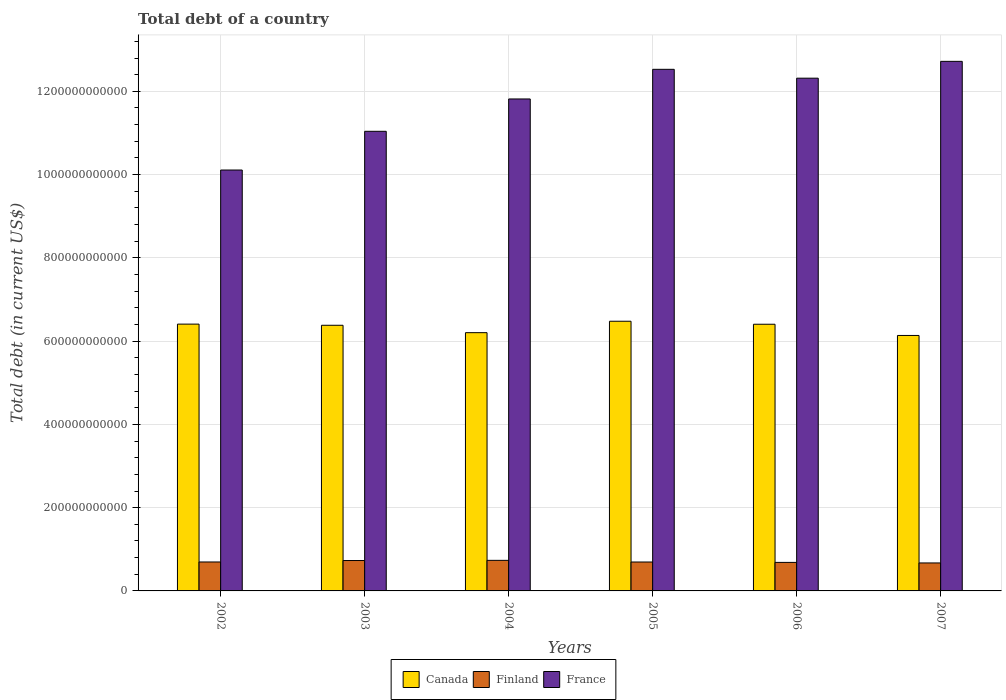How many different coloured bars are there?
Offer a terse response. 3. How many groups of bars are there?
Make the answer very short. 6. Are the number of bars per tick equal to the number of legend labels?
Make the answer very short. Yes. Are the number of bars on each tick of the X-axis equal?
Give a very brief answer. Yes. What is the label of the 2nd group of bars from the left?
Provide a short and direct response. 2003. What is the debt in Canada in 2002?
Keep it short and to the point. 6.41e+11. Across all years, what is the maximum debt in France?
Make the answer very short. 1.27e+12. Across all years, what is the minimum debt in Finland?
Ensure brevity in your answer.  6.72e+1. In which year was the debt in Finland minimum?
Keep it short and to the point. 2007. What is the total debt in France in the graph?
Make the answer very short. 7.05e+12. What is the difference between the debt in France in 2005 and that in 2006?
Your answer should be compact. 2.13e+1. What is the difference between the debt in France in 2002 and the debt in Canada in 2004?
Keep it short and to the point. 3.91e+11. What is the average debt in Canada per year?
Ensure brevity in your answer.  6.34e+11. In the year 2005, what is the difference between the debt in France and debt in Canada?
Keep it short and to the point. 6.05e+11. What is the ratio of the debt in Finland in 2003 to that in 2004?
Provide a succinct answer. 0.99. Is the difference between the debt in France in 2002 and 2007 greater than the difference between the debt in Canada in 2002 and 2007?
Keep it short and to the point. No. What is the difference between the highest and the second highest debt in Canada?
Make the answer very short. 6.89e+09. What is the difference between the highest and the lowest debt in France?
Give a very brief answer. 2.61e+11. What does the 2nd bar from the right in 2006 represents?
Provide a succinct answer. Finland. How many bars are there?
Ensure brevity in your answer.  18. Are all the bars in the graph horizontal?
Your answer should be very brief. No. What is the difference between two consecutive major ticks on the Y-axis?
Provide a succinct answer. 2.00e+11. Does the graph contain grids?
Offer a very short reply. Yes. How many legend labels are there?
Keep it short and to the point. 3. What is the title of the graph?
Your answer should be very brief. Total debt of a country. Does "Puerto Rico" appear as one of the legend labels in the graph?
Your answer should be compact. No. What is the label or title of the Y-axis?
Offer a very short reply. Total debt (in current US$). What is the Total debt (in current US$) of Canada in 2002?
Offer a terse response. 6.41e+11. What is the Total debt (in current US$) of Finland in 2002?
Your response must be concise. 6.95e+1. What is the Total debt (in current US$) in France in 2002?
Make the answer very short. 1.01e+12. What is the Total debt (in current US$) in Canada in 2003?
Keep it short and to the point. 6.38e+11. What is the Total debt (in current US$) of Finland in 2003?
Your answer should be compact. 7.30e+1. What is the Total debt (in current US$) in France in 2003?
Your response must be concise. 1.10e+12. What is the Total debt (in current US$) in Canada in 2004?
Your response must be concise. 6.20e+11. What is the Total debt (in current US$) of Finland in 2004?
Give a very brief answer. 7.34e+1. What is the Total debt (in current US$) of France in 2004?
Provide a succinct answer. 1.18e+12. What is the Total debt (in current US$) of Canada in 2005?
Provide a short and direct response. 6.48e+11. What is the Total debt (in current US$) of Finland in 2005?
Provide a succinct answer. 6.94e+1. What is the Total debt (in current US$) in France in 2005?
Make the answer very short. 1.25e+12. What is the Total debt (in current US$) in Canada in 2006?
Make the answer very short. 6.41e+11. What is the Total debt (in current US$) of Finland in 2006?
Your response must be concise. 6.85e+1. What is the Total debt (in current US$) of France in 2006?
Offer a very short reply. 1.23e+12. What is the Total debt (in current US$) in Canada in 2007?
Your response must be concise. 6.14e+11. What is the Total debt (in current US$) in Finland in 2007?
Offer a terse response. 6.72e+1. What is the Total debt (in current US$) in France in 2007?
Provide a short and direct response. 1.27e+12. Across all years, what is the maximum Total debt (in current US$) in Canada?
Provide a succinct answer. 6.48e+11. Across all years, what is the maximum Total debt (in current US$) of Finland?
Keep it short and to the point. 7.34e+1. Across all years, what is the maximum Total debt (in current US$) in France?
Ensure brevity in your answer.  1.27e+12. Across all years, what is the minimum Total debt (in current US$) of Canada?
Your answer should be very brief. 6.14e+11. Across all years, what is the minimum Total debt (in current US$) of Finland?
Make the answer very short. 6.72e+1. Across all years, what is the minimum Total debt (in current US$) in France?
Make the answer very short. 1.01e+12. What is the total Total debt (in current US$) in Canada in the graph?
Ensure brevity in your answer.  3.80e+12. What is the total Total debt (in current US$) in Finland in the graph?
Offer a terse response. 4.21e+11. What is the total Total debt (in current US$) of France in the graph?
Keep it short and to the point. 7.05e+12. What is the difference between the Total debt (in current US$) of Canada in 2002 and that in 2003?
Your response must be concise. 2.78e+09. What is the difference between the Total debt (in current US$) in Finland in 2002 and that in 2003?
Your answer should be compact. -3.49e+09. What is the difference between the Total debt (in current US$) of France in 2002 and that in 2003?
Offer a terse response. -9.30e+1. What is the difference between the Total debt (in current US$) in Canada in 2002 and that in 2004?
Give a very brief answer. 2.05e+1. What is the difference between the Total debt (in current US$) of Finland in 2002 and that in 2004?
Offer a terse response. -3.91e+09. What is the difference between the Total debt (in current US$) of France in 2002 and that in 2004?
Provide a short and direct response. -1.71e+11. What is the difference between the Total debt (in current US$) of Canada in 2002 and that in 2005?
Give a very brief answer. -6.89e+09. What is the difference between the Total debt (in current US$) of Finland in 2002 and that in 2005?
Keep it short and to the point. 8.10e+07. What is the difference between the Total debt (in current US$) of France in 2002 and that in 2005?
Provide a short and direct response. -2.42e+11. What is the difference between the Total debt (in current US$) of Canada in 2002 and that in 2006?
Ensure brevity in your answer.  3.21e+08. What is the difference between the Total debt (in current US$) in Finland in 2002 and that in 2006?
Keep it short and to the point. 1.01e+09. What is the difference between the Total debt (in current US$) in France in 2002 and that in 2006?
Provide a succinct answer. -2.21e+11. What is the difference between the Total debt (in current US$) in Canada in 2002 and that in 2007?
Keep it short and to the point. 2.73e+1. What is the difference between the Total debt (in current US$) in Finland in 2002 and that in 2007?
Your answer should be compact. 2.33e+09. What is the difference between the Total debt (in current US$) in France in 2002 and that in 2007?
Offer a terse response. -2.61e+11. What is the difference between the Total debt (in current US$) in Canada in 2003 and that in 2004?
Provide a succinct answer. 1.78e+1. What is the difference between the Total debt (in current US$) of Finland in 2003 and that in 2004?
Your answer should be compact. -4.24e+08. What is the difference between the Total debt (in current US$) in France in 2003 and that in 2004?
Give a very brief answer. -7.77e+1. What is the difference between the Total debt (in current US$) of Canada in 2003 and that in 2005?
Offer a terse response. -9.66e+09. What is the difference between the Total debt (in current US$) in Finland in 2003 and that in 2005?
Keep it short and to the point. 3.57e+09. What is the difference between the Total debt (in current US$) in France in 2003 and that in 2005?
Your answer should be compact. -1.49e+11. What is the difference between the Total debt (in current US$) of Canada in 2003 and that in 2006?
Ensure brevity in your answer.  -2.46e+09. What is the difference between the Total debt (in current US$) in Finland in 2003 and that in 2006?
Ensure brevity in your answer.  4.50e+09. What is the difference between the Total debt (in current US$) in France in 2003 and that in 2006?
Keep it short and to the point. -1.28e+11. What is the difference between the Total debt (in current US$) in Canada in 2003 and that in 2007?
Provide a short and direct response. 2.45e+1. What is the difference between the Total debt (in current US$) in Finland in 2003 and that in 2007?
Provide a succinct answer. 5.82e+09. What is the difference between the Total debt (in current US$) of France in 2003 and that in 2007?
Provide a short and direct response. -1.68e+11. What is the difference between the Total debt (in current US$) in Canada in 2004 and that in 2005?
Your response must be concise. -2.74e+1. What is the difference between the Total debt (in current US$) in Finland in 2004 and that in 2005?
Keep it short and to the point. 3.99e+09. What is the difference between the Total debt (in current US$) of France in 2004 and that in 2005?
Ensure brevity in your answer.  -7.12e+1. What is the difference between the Total debt (in current US$) of Canada in 2004 and that in 2006?
Ensure brevity in your answer.  -2.02e+1. What is the difference between the Total debt (in current US$) of Finland in 2004 and that in 2006?
Your answer should be compact. 4.93e+09. What is the difference between the Total debt (in current US$) of France in 2004 and that in 2006?
Offer a very short reply. -4.99e+1. What is the difference between the Total debt (in current US$) in Canada in 2004 and that in 2007?
Offer a very short reply. 6.72e+09. What is the difference between the Total debt (in current US$) in Finland in 2004 and that in 2007?
Your answer should be compact. 6.24e+09. What is the difference between the Total debt (in current US$) of France in 2004 and that in 2007?
Your answer should be compact. -9.03e+1. What is the difference between the Total debt (in current US$) of Canada in 2005 and that in 2006?
Provide a short and direct response. 7.21e+09. What is the difference between the Total debt (in current US$) of Finland in 2005 and that in 2006?
Provide a short and direct response. 9.33e+08. What is the difference between the Total debt (in current US$) in France in 2005 and that in 2006?
Provide a succinct answer. 2.13e+1. What is the difference between the Total debt (in current US$) in Canada in 2005 and that in 2007?
Keep it short and to the point. 3.42e+1. What is the difference between the Total debt (in current US$) of Finland in 2005 and that in 2007?
Ensure brevity in your answer.  2.25e+09. What is the difference between the Total debt (in current US$) in France in 2005 and that in 2007?
Your answer should be very brief. -1.91e+1. What is the difference between the Total debt (in current US$) of Canada in 2006 and that in 2007?
Your response must be concise. 2.69e+1. What is the difference between the Total debt (in current US$) of Finland in 2006 and that in 2007?
Provide a succinct answer. 1.32e+09. What is the difference between the Total debt (in current US$) in France in 2006 and that in 2007?
Offer a terse response. -4.04e+1. What is the difference between the Total debt (in current US$) of Canada in 2002 and the Total debt (in current US$) of Finland in 2003?
Your answer should be very brief. 5.68e+11. What is the difference between the Total debt (in current US$) in Canada in 2002 and the Total debt (in current US$) in France in 2003?
Keep it short and to the point. -4.63e+11. What is the difference between the Total debt (in current US$) in Finland in 2002 and the Total debt (in current US$) in France in 2003?
Ensure brevity in your answer.  -1.03e+12. What is the difference between the Total debt (in current US$) in Canada in 2002 and the Total debt (in current US$) in Finland in 2004?
Keep it short and to the point. 5.67e+11. What is the difference between the Total debt (in current US$) of Canada in 2002 and the Total debt (in current US$) of France in 2004?
Offer a very short reply. -5.41e+11. What is the difference between the Total debt (in current US$) in Finland in 2002 and the Total debt (in current US$) in France in 2004?
Make the answer very short. -1.11e+12. What is the difference between the Total debt (in current US$) in Canada in 2002 and the Total debt (in current US$) in Finland in 2005?
Give a very brief answer. 5.71e+11. What is the difference between the Total debt (in current US$) of Canada in 2002 and the Total debt (in current US$) of France in 2005?
Give a very brief answer. -6.12e+11. What is the difference between the Total debt (in current US$) of Finland in 2002 and the Total debt (in current US$) of France in 2005?
Make the answer very short. -1.18e+12. What is the difference between the Total debt (in current US$) of Canada in 2002 and the Total debt (in current US$) of Finland in 2006?
Ensure brevity in your answer.  5.72e+11. What is the difference between the Total debt (in current US$) in Canada in 2002 and the Total debt (in current US$) in France in 2006?
Your answer should be compact. -5.91e+11. What is the difference between the Total debt (in current US$) in Finland in 2002 and the Total debt (in current US$) in France in 2006?
Your answer should be very brief. -1.16e+12. What is the difference between the Total debt (in current US$) in Canada in 2002 and the Total debt (in current US$) in Finland in 2007?
Your answer should be compact. 5.74e+11. What is the difference between the Total debt (in current US$) of Canada in 2002 and the Total debt (in current US$) of France in 2007?
Your answer should be compact. -6.31e+11. What is the difference between the Total debt (in current US$) in Finland in 2002 and the Total debt (in current US$) in France in 2007?
Your answer should be compact. -1.20e+12. What is the difference between the Total debt (in current US$) of Canada in 2003 and the Total debt (in current US$) of Finland in 2004?
Keep it short and to the point. 5.65e+11. What is the difference between the Total debt (in current US$) of Canada in 2003 and the Total debt (in current US$) of France in 2004?
Give a very brief answer. -5.44e+11. What is the difference between the Total debt (in current US$) in Finland in 2003 and the Total debt (in current US$) in France in 2004?
Keep it short and to the point. -1.11e+12. What is the difference between the Total debt (in current US$) of Canada in 2003 and the Total debt (in current US$) of Finland in 2005?
Give a very brief answer. 5.69e+11. What is the difference between the Total debt (in current US$) of Canada in 2003 and the Total debt (in current US$) of France in 2005?
Make the answer very short. -6.15e+11. What is the difference between the Total debt (in current US$) in Finland in 2003 and the Total debt (in current US$) in France in 2005?
Ensure brevity in your answer.  -1.18e+12. What is the difference between the Total debt (in current US$) of Canada in 2003 and the Total debt (in current US$) of Finland in 2006?
Ensure brevity in your answer.  5.70e+11. What is the difference between the Total debt (in current US$) in Canada in 2003 and the Total debt (in current US$) in France in 2006?
Ensure brevity in your answer.  -5.94e+11. What is the difference between the Total debt (in current US$) of Finland in 2003 and the Total debt (in current US$) of France in 2006?
Make the answer very short. -1.16e+12. What is the difference between the Total debt (in current US$) in Canada in 2003 and the Total debt (in current US$) in Finland in 2007?
Ensure brevity in your answer.  5.71e+11. What is the difference between the Total debt (in current US$) in Canada in 2003 and the Total debt (in current US$) in France in 2007?
Your answer should be very brief. -6.34e+11. What is the difference between the Total debt (in current US$) in Finland in 2003 and the Total debt (in current US$) in France in 2007?
Keep it short and to the point. -1.20e+12. What is the difference between the Total debt (in current US$) in Canada in 2004 and the Total debt (in current US$) in Finland in 2005?
Your answer should be very brief. 5.51e+11. What is the difference between the Total debt (in current US$) of Canada in 2004 and the Total debt (in current US$) of France in 2005?
Ensure brevity in your answer.  -6.33e+11. What is the difference between the Total debt (in current US$) of Finland in 2004 and the Total debt (in current US$) of France in 2005?
Provide a short and direct response. -1.18e+12. What is the difference between the Total debt (in current US$) of Canada in 2004 and the Total debt (in current US$) of Finland in 2006?
Your answer should be very brief. 5.52e+11. What is the difference between the Total debt (in current US$) in Canada in 2004 and the Total debt (in current US$) in France in 2006?
Give a very brief answer. -6.11e+11. What is the difference between the Total debt (in current US$) of Finland in 2004 and the Total debt (in current US$) of France in 2006?
Keep it short and to the point. -1.16e+12. What is the difference between the Total debt (in current US$) of Canada in 2004 and the Total debt (in current US$) of Finland in 2007?
Keep it short and to the point. 5.53e+11. What is the difference between the Total debt (in current US$) in Canada in 2004 and the Total debt (in current US$) in France in 2007?
Your answer should be very brief. -6.52e+11. What is the difference between the Total debt (in current US$) of Finland in 2004 and the Total debt (in current US$) of France in 2007?
Ensure brevity in your answer.  -1.20e+12. What is the difference between the Total debt (in current US$) in Canada in 2005 and the Total debt (in current US$) in Finland in 2006?
Offer a very short reply. 5.79e+11. What is the difference between the Total debt (in current US$) of Canada in 2005 and the Total debt (in current US$) of France in 2006?
Your answer should be compact. -5.84e+11. What is the difference between the Total debt (in current US$) in Finland in 2005 and the Total debt (in current US$) in France in 2006?
Keep it short and to the point. -1.16e+12. What is the difference between the Total debt (in current US$) in Canada in 2005 and the Total debt (in current US$) in Finland in 2007?
Offer a very short reply. 5.81e+11. What is the difference between the Total debt (in current US$) in Canada in 2005 and the Total debt (in current US$) in France in 2007?
Your answer should be very brief. -6.24e+11. What is the difference between the Total debt (in current US$) of Finland in 2005 and the Total debt (in current US$) of France in 2007?
Provide a short and direct response. -1.20e+12. What is the difference between the Total debt (in current US$) in Canada in 2006 and the Total debt (in current US$) in Finland in 2007?
Offer a very short reply. 5.73e+11. What is the difference between the Total debt (in current US$) in Canada in 2006 and the Total debt (in current US$) in France in 2007?
Your answer should be very brief. -6.31e+11. What is the difference between the Total debt (in current US$) of Finland in 2006 and the Total debt (in current US$) of France in 2007?
Keep it short and to the point. -1.20e+12. What is the average Total debt (in current US$) in Canada per year?
Keep it short and to the point. 6.34e+11. What is the average Total debt (in current US$) of Finland per year?
Provide a succinct answer. 7.02e+1. What is the average Total debt (in current US$) in France per year?
Your answer should be very brief. 1.18e+12. In the year 2002, what is the difference between the Total debt (in current US$) of Canada and Total debt (in current US$) of Finland?
Your answer should be very brief. 5.71e+11. In the year 2002, what is the difference between the Total debt (in current US$) in Canada and Total debt (in current US$) in France?
Your answer should be compact. -3.70e+11. In the year 2002, what is the difference between the Total debt (in current US$) in Finland and Total debt (in current US$) in France?
Provide a short and direct response. -9.41e+11. In the year 2003, what is the difference between the Total debt (in current US$) of Canada and Total debt (in current US$) of Finland?
Your answer should be very brief. 5.65e+11. In the year 2003, what is the difference between the Total debt (in current US$) of Canada and Total debt (in current US$) of France?
Offer a very short reply. -4.66e+11. In the year 2003, what is the difference between the Total debt (in current US$) of Finland and Total debt (in current US$) of France?
Keep it short and to the point. -1.03e+12. In the year 2004, what is the difference between the Total debt (in current US$) of Canada and Total debt (in current US$) of Finland?
Keep it short and to the point. 5.47e+11. In the year 2004, what is the difference between the Total debt (in current US$) in Canada and Total debt (in current US$) in France?
Your answer should be compact. -5.61e+11. In the year 2004, what is the difference between the Total debt (in current US$) of Finland and Total debt (in current US$) of France?
Offer a terse response. -1.11e+12. In the year 2005, what is the difference between the Total debt (in current US$) of Canada and Total debt (in current US$) of Finland?
Your answer should be very brief. 5.78e+11. In the year 2005, what is the difference between the Total debt (in current US$) in Canada and Total debt (in current US$) in France?
Offer a very short reply. -6.05e+11. In the year 2005, what is the difference between the Total debt (in current US$) in Finland and Total debt (in current US$) in France?
Provide a short and direct response. -1.18e+12. In the year 2006, what is the difference between the Total debt (in current US$) in Canada and Total debt (in current US$) in Finland?
Make the answer very short. 5.72e+11. In the year 2006, what is the difference between the Total debt (in current US$) of Canada and Total debt (in current US$) of France?
Offer a terse response. -5.91e+11. In the year 2006, what is the difference between the Total debt (in current US$) of Finland and Total debt (in current US$) of France?
Offer a terse response. -1.16e+12. In the year 2007, what is the difference between the Total debt (in current US$) in Canada and Total debt (in current US$) in Finland?
Offer a terse response. 5.46e+11. In the year 2007, what is the difference between the Total debt (in current US$) of Canada and Total debt (in current US$) of France?
Ensure brevity in your answer.  -6.58e+11. In the year 2007, what is the difference between the Total debt (in current US$) in Finland and Total debt (in current US$) in France?
Your answer should be very brief. -1.20e+12. What is the ratio of the Total debt (in current US$) of Finland in 2002 to that in 2003?
Provide a short and direct response. 0.95. What is the ratio of the Total debt (in current US$) in France in 2002 to that in 2003?
Keep it short and to the point. 0.92. What is the ratio of the Total debt (in current US$) in Canada in 2002 to that in 2004?
Offer a terse response. 1.03. What is the ratio of the Total debt (in current US$) in Finland in 2002 to that in 2004?
Offer a very short reply. 0.95. What is the ratio of the Total debt (in current US$) in France in 2002 to that in 2004?
Offer a very short reply. 0.86. What is the ratio of the Total debt (in current US$) of Canada in 2002 to that in 2005?
Your answer should be compact. 0.99. What is the ratio of the Total debt (in current US$) of Finland in 2002 to that in 2005?
Provide a succinct answer. 1. What is the ratio of the Total debt (in current US$) of France in 2002 to that in 2005?
Provide a short and direct response. 0.81. What is the ratio of the Total debt (in current US$) of Canada in 2002 to that in 2006?
Offer a terse response. 1. What is the ratio of the Total debt (in current US$) of Finland in 2002 to that in 2006?
Offer a terse response. 1.01. What is the ratio of the Total debt (in current US$) of France in 2002 to that in 2006?
Offer a very short reply. 0.82. What is the ratio of the Total debt (in current US$) in Canada in 2002 to that in 2007?
Provide a succinct answer. 1.04. What is the ratio of the Total debt (in current US$) of Finland in 2002 to that in 2007?
Keep it short and to the point. 1.03. What is the ratio of the Total debt (in current US$) in France in 2002 to that in 2007?
Offer a terse response. 0.79. What is the ratio of the Total debt (in current US$) of Canada in 2003 to that in 2004?
Offer a very short reply. 1.03. What is the ratio of the Total debt (in current US$) of France in 2003 to that in 2004?
Make the answer very short. 0.93. What is the ratio of the Total debt (in current US$) of Canada in 2003 to that in 2005?
Provide a succinct answer. 0.99. What is the ratio of the Total debt (in current US$) in Finland in 2003 to that in 2005?
Your answer should be very brief. 1.05. What is the ratio of the Total debt (in current US$) in France in 2003 to that in 2005?
Provide a short and direct response. 0.88. What is the ratio of the Total debt (in current US$) of Finland in 2003 to that in 2006?
Your answer should be compact. 1.07. What is the ratio of the Total debt (in current US$) of France in 2003 to that in 2006?
Offer a very short reply. 0.9. What is the ratio of the Total debt (in current US$) in Canada in 2003 to that in 2007?
Give a very brief answer. 1.04. What is the ratio of the Total debt (in current US$) of Finland in 2003 to that in 2007?
Your answer should be very brief. 1.09. What is the ratio of the Total debt (in current US$) of France in 2003 to that in 2007?
Your answer should be very brief. 0.87. What is the ratio of the Total debt (in current US$) of Canada in 2004 to that in 2005?
Your response must be concise. 0.96. What is the ratio of the Total debt (in current US$) of Finland in 2004 to that in 2005?
Your answer should be very brief. 1.06. What is the ratio of the Total debt (in current US$) in France in 2004 to that in 2005?
Your answer should be compact. 0.94. What is the ratio of the Total debt (in current US$) of Canada in 2004 to that in 2006?
Your response must be concise. 0.97. What is the ratio of the Total debt (in current US$) of Finland in 2004 to that in 2006?
Ensure brevity in your answer.  1.07. What is the ratio of the Total debt (in current US$) in France in 2004 to that in 2006?
Make the answer very short. 0.96. What is the ratio of the Total debt (in current US$) of Canada in 2004 to that in 2007?
Offer a very short reply. 1.01. What is the ratio of the Total debt (in current US$) of Finland in 2004 to that in 2007?
Give a very brief answer. 1.09. What is the ratio of the Total debt (in current US$) in France in 2004 to that in 2007?
Your response must be concise. 0.93. What is the ratio of the Total debt (in current US$) in Canada in 2005 to that in 2006?
Keep it short and to the point. 1.01. What is the ratio of the Total debt (in current US$) of Finland in 2005 to that in 2006?
Give a very brief answer. 1.01. What is the ratio of the Total debt (in current US$) in France in 2005 to that in 2006?
Offer a very short reply. 1.02. What is the ratio of the Total debt (in current US$) in Canada in 2005 to that in 2007?
Provide a short and direct response. 1.06. What is the ratio of the Total debt (in current US$) in Finland in 2005 to that in 2007?
Offer a very short reply. 1.03. What is the ratio of the Total debt (in current US$) in France in 2005 to that in 2007?
Give a very brief answer. 0.98. What is the ratio of the Total debt (in current US$) in Canada in 2006 to that in 2007?
Your answer should be compact. 1.04. What is the ratio of the Total debt (in current US$) of Finland in 2006 to that in 2007?
Offer a very short reply. 1.02. What is the ratio of the Total debt (in current US$) in France in 2006 to that in 2007?
Your answer should be compact. 0.97. What is the difference between the highest and the second highest Total debt (in current US$) of Canada?
Provide a succinct answer. 6.89e+09. What is the difference between the highest and the second highest Total debt (in current US$) in Finland?
Give a very brief answer. 4.24e+08. What is the difference between the highest and the second highest Total debt (in current US$) of France?
Give a very brief answer. 1.91e+1. What is the difference between the highest and the lowest Total debt (in current US$) of Canada?
Keep it short and to the point. 3.42e+1. What is the difference between the highest and the lowest Total debt (in current US$) of Finland?
Your answer should be very brief. 6.24e+09. What is the difference between the highest and the lowest Total debt (in current US$) of France?
Provide a succinct answer. 2.61e+11. 